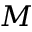<formula> <loc_0><loc_0><loc_500><loc_500>M</formula> 